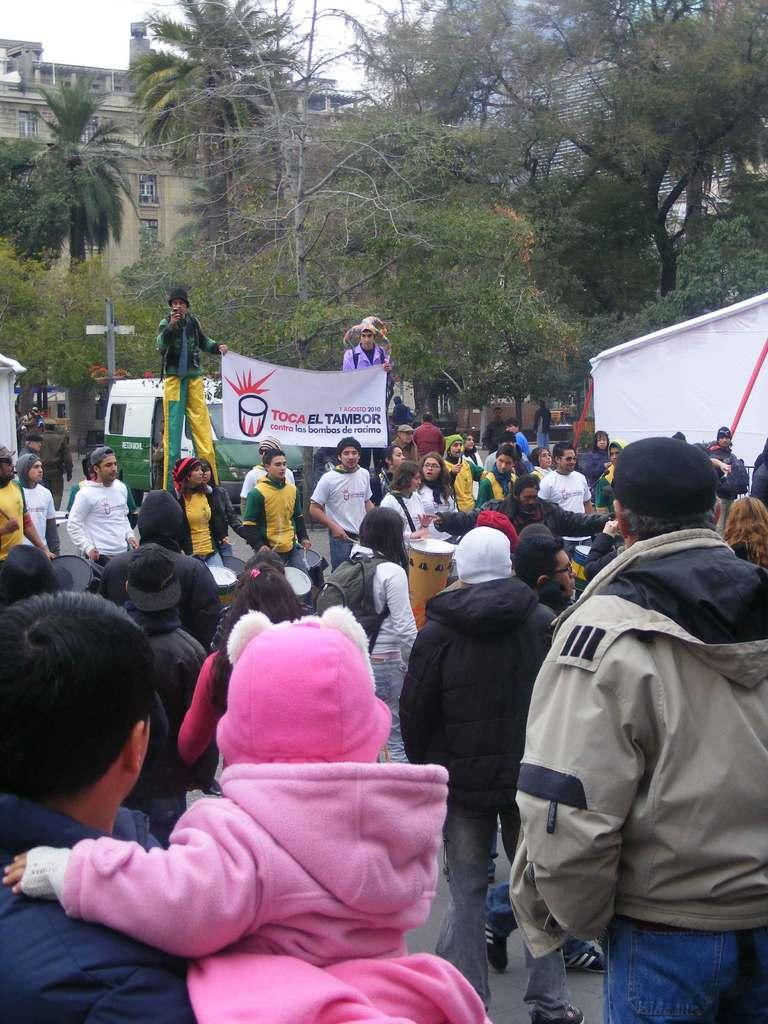What are the people in the image doing? The people in the image are playing musical drums. Are there any objects or accessories related to their activity? Two people are holding a banner. What can be seen in the background of the image? There are trees, a building with windows, and a vehicle in the background of the image. What type of house is being cooked in the image? There is no house or cooking activity present in the image. How many people are pulling the vehicle in the image? There is no vehicle being pulled in the image; it is stationary in the background. 